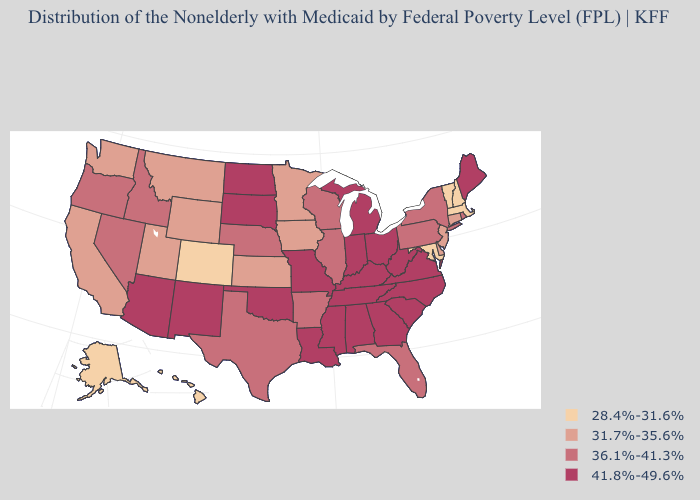Does the map have missing data?
Short answer required. No. Name the states that have a value in the range 36.1%-41.3%?
Quick response, please. Arkansas, Florida, Idaho, Illinois, Nebraska, Nevada, New York, Oregon, Pennsylvania, Rhode Island, Texas, Wisconsin. Is the legend a continuous bar?
Concise answer only. No. Does Oklahoma have a lower value than Vermont?
Short answer required. No. Which states hav the highest value in the South?
Concise answer only. Alabama, Georgia, Kentucky, Louisiana, Mississippi, North Carolina, Oklahoma, South Carolina, Tennessee, Virginia, West Virginia. Does the first symbol in the legend represent the smallest category?
Write a very short answer. Yes. Name the states that have a value in the range 28.4%-31.6%?
Answer briefly. Alaska, Colorado, Hawaii, Maryland, Massachusetts, New Hampshire, Vermont. What is the value of Vermont?
Give a very brief answer. 28.4%-31.6%. What is the value of Washington?
Short answer required. 31.7%-35.6%. Name the states that have a value in the range 36.1%-41.3%?
Give a very brief answer. Arkansas, Florida, Idaho, Illinois, Nebraska, Nevada, New York, Oregon, Pennsylvania, Rhode Island, Texas, Wisconsin. Name the states that have a value in the range 36.1%-41.3%?
Quick response, please. Arkansas, Florida, Idaho, Illinois, Nebraska, Nevada, New York, Oregon, Pennsylvania, Rhode Island, Texas, Wisconsin. How many symbols are there in the legend?
Be succinct. 4. Name the states that have a value in the range 41.8%-49.6%?
Be succinct. Alabama, Arizona, Georgia, Indiana, Kentucky, Louisiana, Maine, Michigan, Mississippi, Missouri, New Mexico, North Carolina, North Dakota, Ohio, Oklahoma, South Carolina, South Dakota, Tennessee, Virginia, West Virginia. Among the states that border Connecticut , which have the highest value?
Keep it brief. New York, Rhode Island. What is the lowest value in the USA?
Concise answer only. 28.4%-31.6%. 